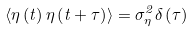Convert formula to latex. <formula><loc_0><loc_0><loc_500><loc_500>\left \langle \eta \left ( t \right ) \eta \left ( t + \tau \right ) \right \rangle = \sigma _ { \eta } ^ { 2 } \delta \left ( \tau \right )</formula> 